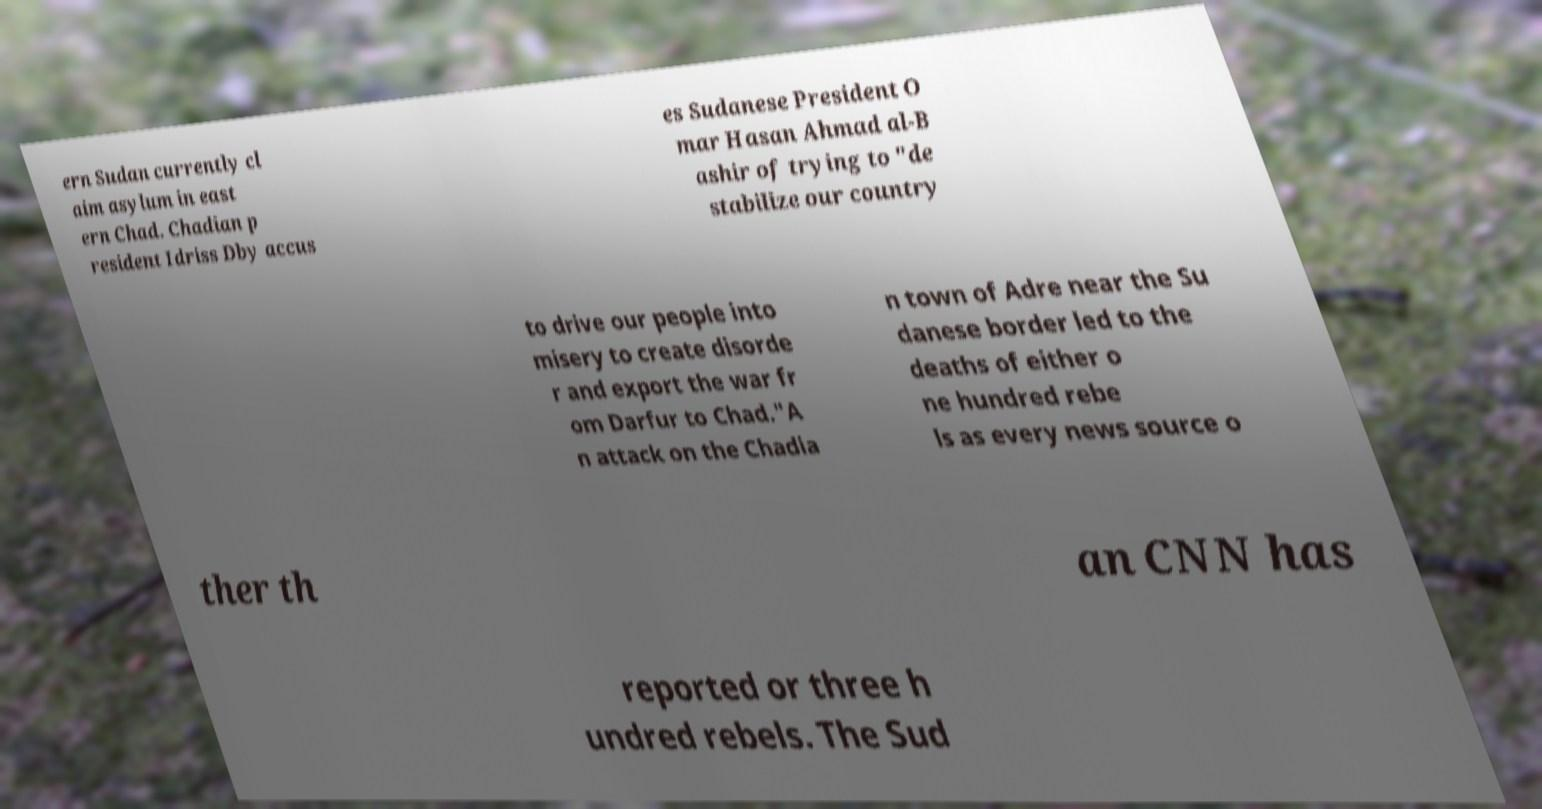Can you read and provide the text displayed in the image?This photo seems to have some interesting text. Can you extract and type it out for me? ern Sudan currently cl aim asylum in east ern Chad. Chadian p resident Idriss Dby accus es Sudanese President O mar Hasan Ahmad al-B ashir of trying to "de stabilize our country to drive our people into misery to create disorde r and export the war fr om Darfur to Chad."A n attack on the Chadia n town of Adre near the Su danese border led to the deaths of either o ne hundred rebe ls as every news source o ther th an CNN has reported or three h undred rebels. The Sud 